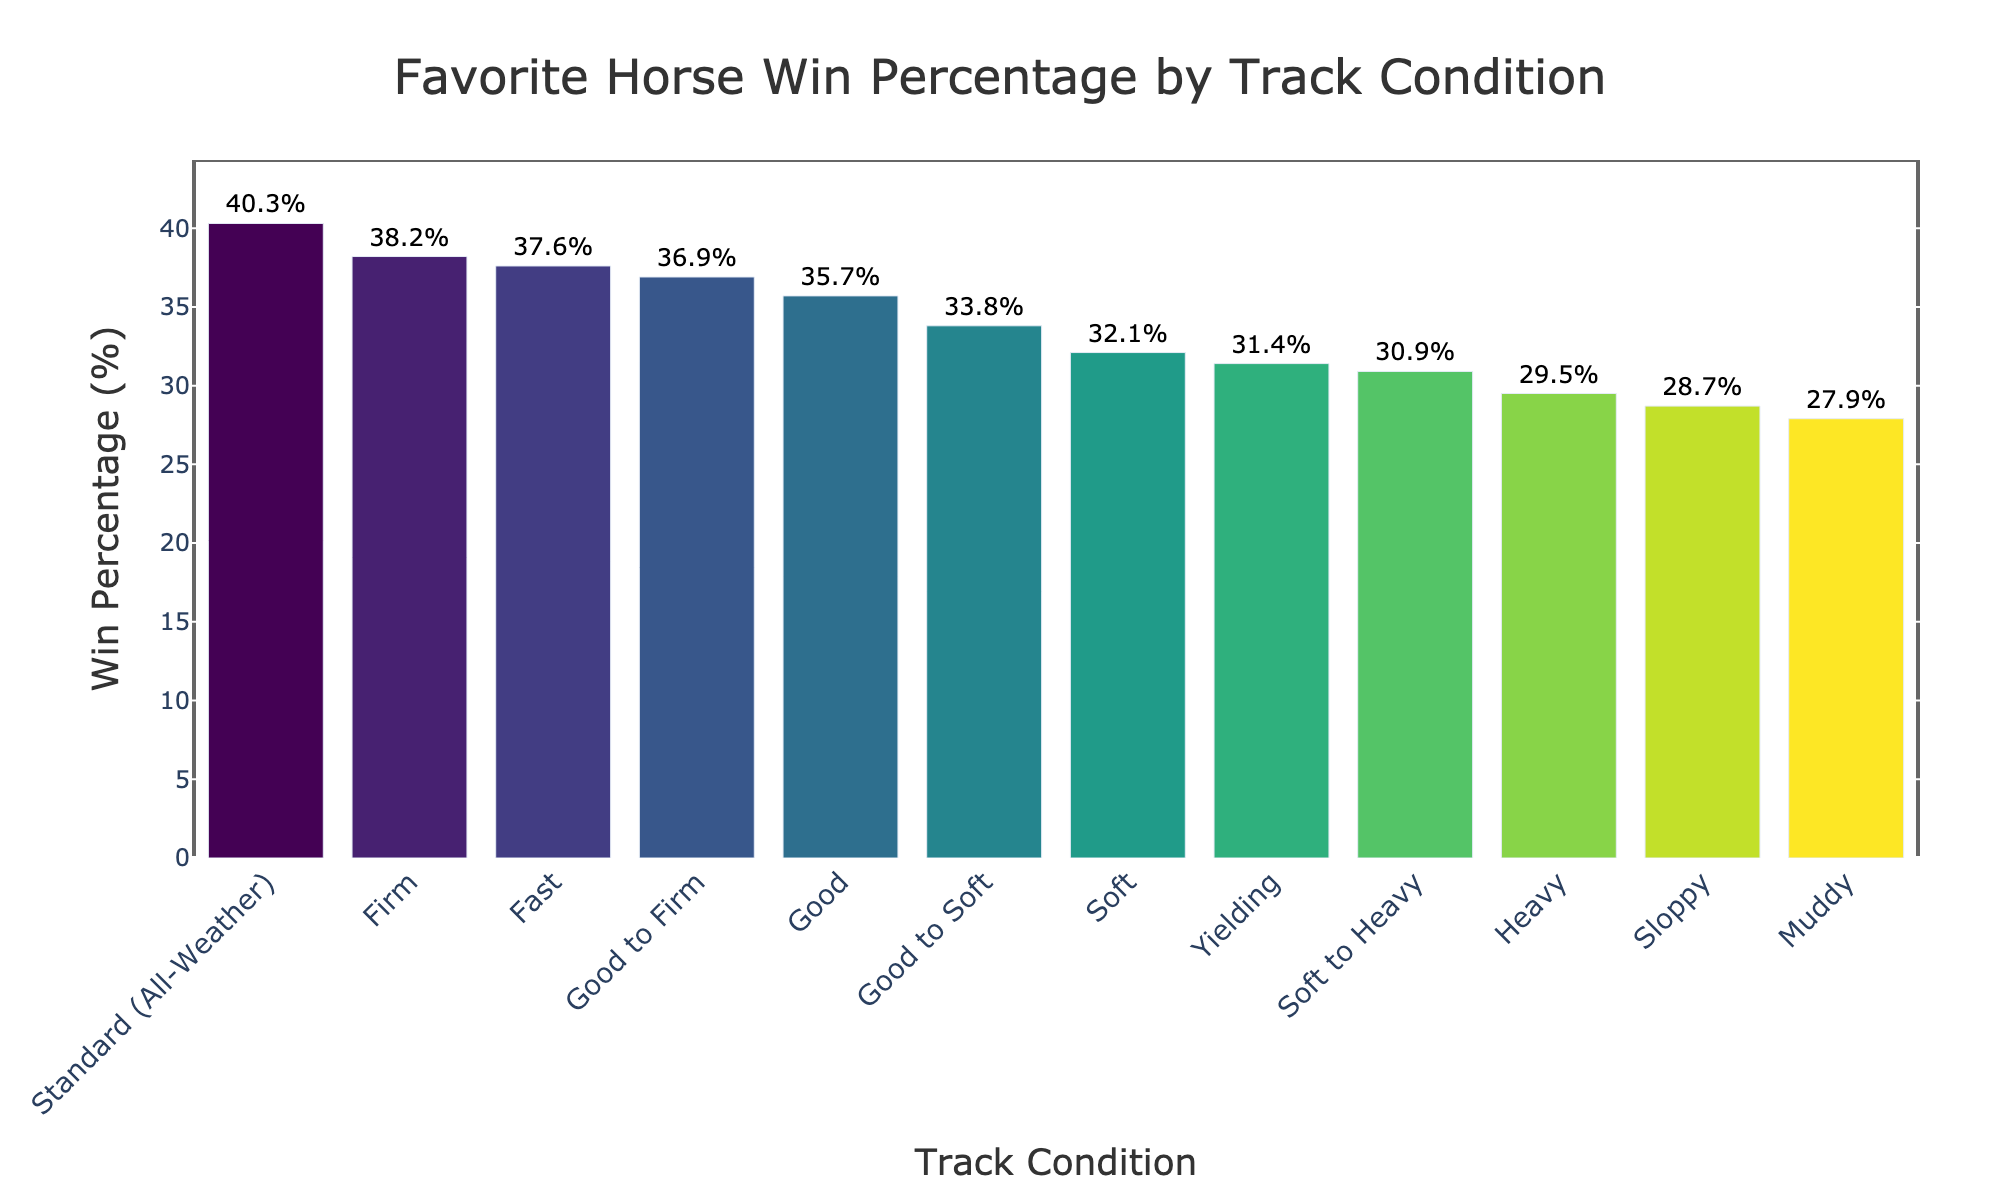What's the win percentage of favorite horses on a 'Firm' track? Locate the bar corresponding to 'Firm' on the x-axis. The text label above the bar shows the win percentage.
Answer: 38.2% Which track condition has the highest favorite win percentage? Identify the tallest bar in the graph and read the corresponding track condition label on the x-axis.
Answer: Standard (All-Weather) How much higher is the win percentage on a 'Standard (All-Weather)' track compared to a 'Soft' track? Check the win percentages for 'Standard (All-Weather)' and 'Soft'. Subtract the win percentage of 'Soft' from 'Standard (All-Weather)': 40.3 - 32.1.
Answer: 8.2% What's the average win percentage for 'Firm', 'Good', and 'Soft' track conditions? Sum the win percentages for 'Firm', 'Good', and 'Soft' and divide by 3: (38.2 + 35.7 + 32.1) / 3.
Answer: 35.3% Which track condition has a lower win percentage, 'Muddy' or 'Yielding'? Compare the heights of the bars for 'Muddy' and 'Yielding'. 'Muddy' has a lower win percentage than 'Yielding'.
Answer: Muddy What is the range of win percentages shown in the plot? The range is the difference between the highest and lowest win percentages shown on the y-axis. The highest is 40.3% (Standard (All-Weather)) and the lowest is 27.9% (Muddy). So, the range is 40.3 - 27.9.
Answer: 12.4% How many track conditions have a win percentage higher than 35%? Identify the bars with percentages above 35%. Count the relevant bars: 'Firm', 'Good to Firm', 'Standard (All-Weather)', and 'Fast'.
Answer: 4 If the win percentage on 'Good' conditions improved by 5%, what would it be? Add 5 to the current win percentage for 'Good': 35.7 + 5.
Answer: 40.7% Is the win percentage for 'Sloppy' track conditions above or below 30%? Locate the 'Sloppy' bar and check its percentage. It is 28.7%, which is below 30%.
Answer: Below What’s the sum of the win percentages for 'Heavy' and 'Soft to Heavy' conditions? Add the win percentages for 'Heavy' and 'Soft to Heavy': 29.5 + 30.9.
Answer: 60.4 